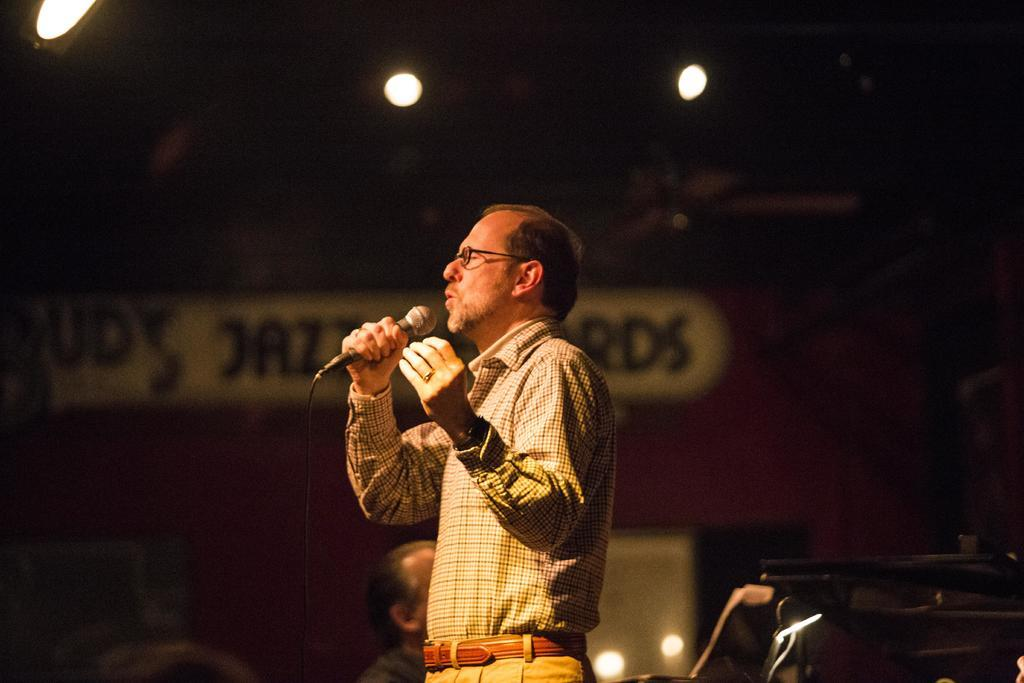Who is the main subject in the image? There is a man in the image. What is the man doing in the image? The man is singing on a microphone. Can you describe the background of the image? The background of the image is dark. What can be seen on the ceiling in the image? There are lights on the ceiling in the image. What type of mountain is visible in the background of the image? There is no mountain visible in the background of the image; it has a dark background. What color are the man's trousers in the image? The provided facts do not mention the color of the man's trousers, so we cannot determine that information from the image. 